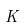Convert formula to latex. <formula><loc_0><loc_0><loc_500><loc_500>K</formula> 